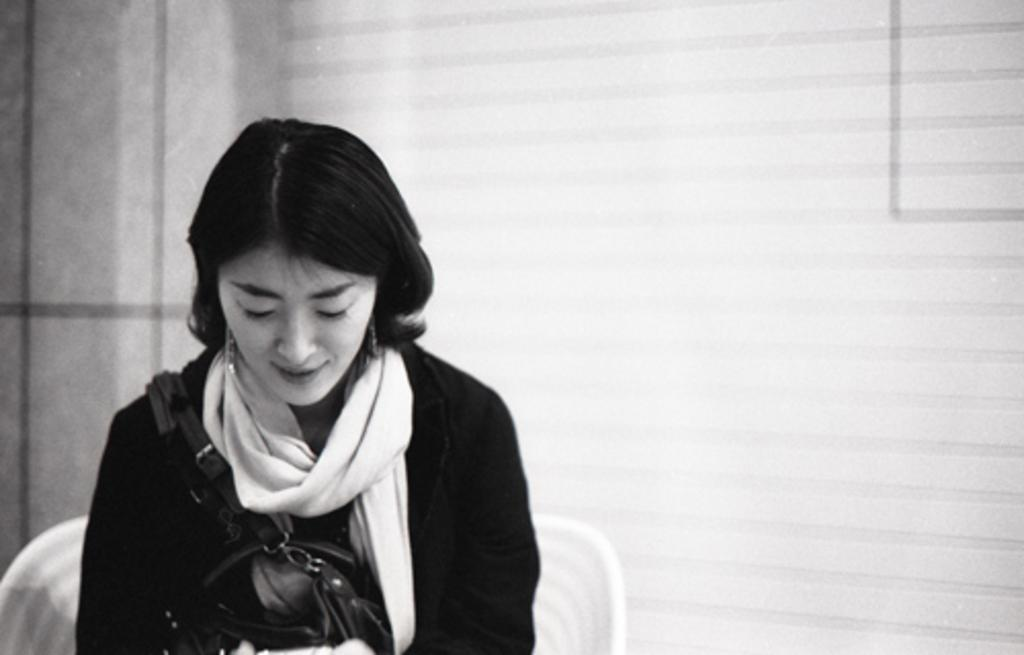Who is present in the image? There is a woman in the image. What is the woman doing in the image? The woman is sitting on a chair. What can be seen behind the woman in the image? There is a wall visible in the background of the image. Where might this image have been taken? The image is likely taken in a room, given the presence of a wall in the background. What type of bear can be seen playing baseball in the image? There is no bear or baseball present in the image; it features a woman sitting on a chair in a room. 